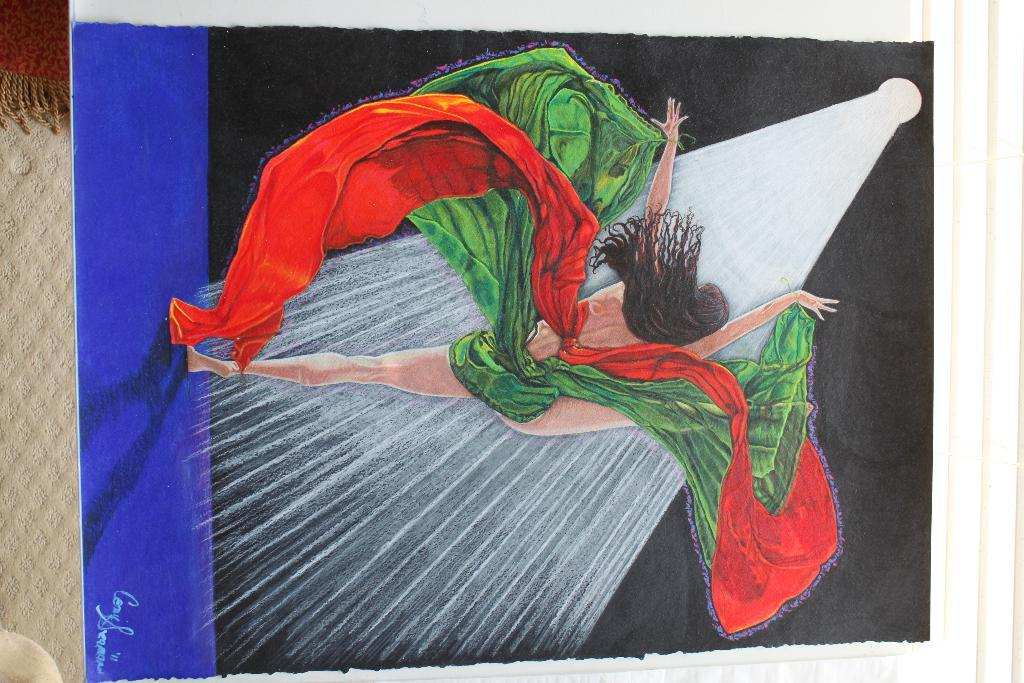What is the main subject of the image? There is a painting in the center of the image. What can be seen in the background of the image? There is a wall in the background of the image. Is there any window treatment present in the image? Yes, there is a curtain associated with the wall in the background. What type of crate is visible in the image? There is no crate present in the image. What color is the silver object in the image? There is no silver object present in the image. 